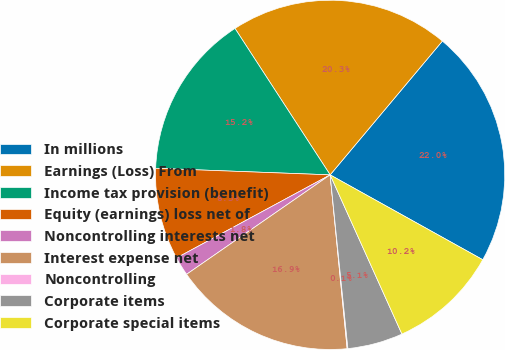<chart> <loc_0><loc_0><loc_500><loc_500><pie_chart><fcel>In millions<fcel>Earnings (Loss) From<fcel>Income tax provision (benefit)<fcel>Equity (earnings) loss net of<fcel>Noncontrolling interests net<fcel>Interest expense net<fcel>Noncontrolling<fcel>Corporate items<fcel>Corporate special items<nl><fcel>21.97%<fcel>20.28%<fcel>15.23%<fcel>8.49%<fcel>1.75%<fcel>16.91%<fcel>0.07%<fcel>5.12%<fcel>10.18%<nl></chart> 